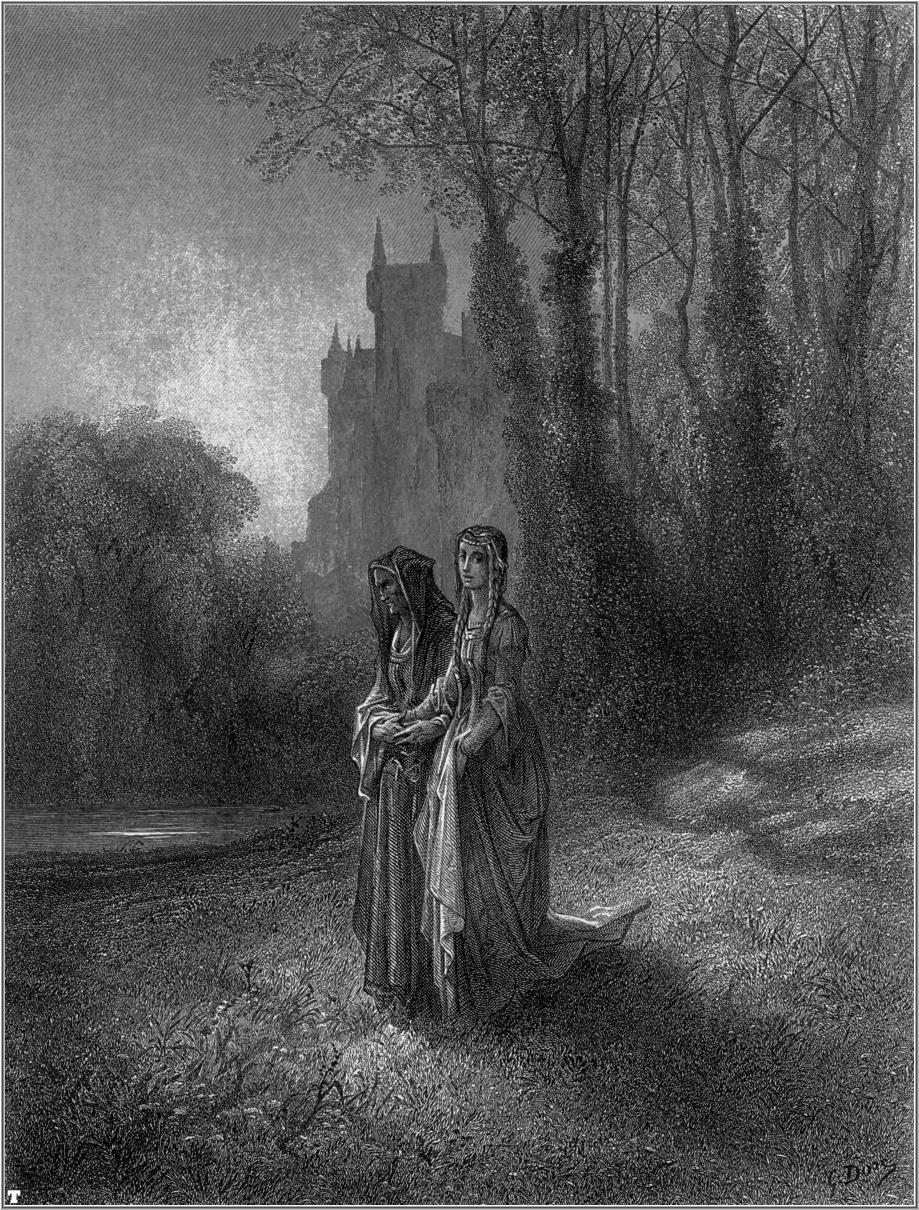Imagine a story that could be taking place in this scene. In this serene forest, Lady Eleanor and her sister, Isabella, have embarked on their regular morning walk. They have grown up in the majestic castle visible in the background, surrounded by tales of knights and dragons. Today, however, as they walk along the familiar path, Eleanor carries an old family heirloom in her basket - a locket that has been in their family for generations. They are on their way to a secluded clearing in the forest, a place their grandmother called 'The Enchanted Grove.' Legend has it that the grove holds the power to reveal the future to those who offer it something precious. Eleanor and Isabella, both troubled by recent ominous dreams, hope to uncover what lies ahead and protect their beloved home from impending danger. 